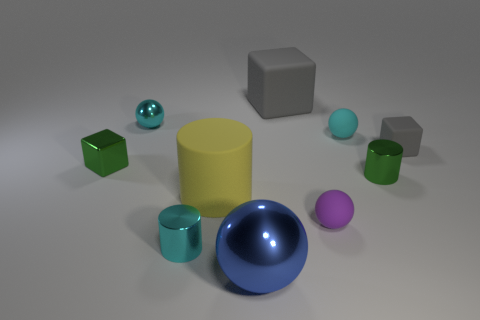There is a blue shiny thing that is the same shape as the small purple matte thing; what is its size?
Ensure brevity in your answer.  Large. Is there anything else that has the same size as the green metallic cube?
Give a very brief answer. Yes. There is a small green object that is left of the small green shiny thing right of the large gray cube; what is its material?
Your response must be concise. Metal. How many metallic objects are either large blocks or tiny yellow blocks?
Offer a terse response. 0. There is another rubber thing that is the same shape as the small cyan rubber thing; what color is it?
Make the answer very short. Purple. How many large metal things have the same color as the big rubber cylinder?
Ensure brevity in your answer.  0. Is there a purple rubber object that is to the left of the small cyan thing in front of the small gray cube?
Offer a terse response. No. What number of small metallic objects are in front of the tiny gray thing and behind the tiny cyan rubber sphere?
Your answer should be compact. 0. How many small cyan cylinders are made of the same material as the blue ball?
Make the answer very short. 1. What is the size of the gray rubber block behind the rubber cube that is to the right of the large gray block?
Offer a very short reply. Large. 